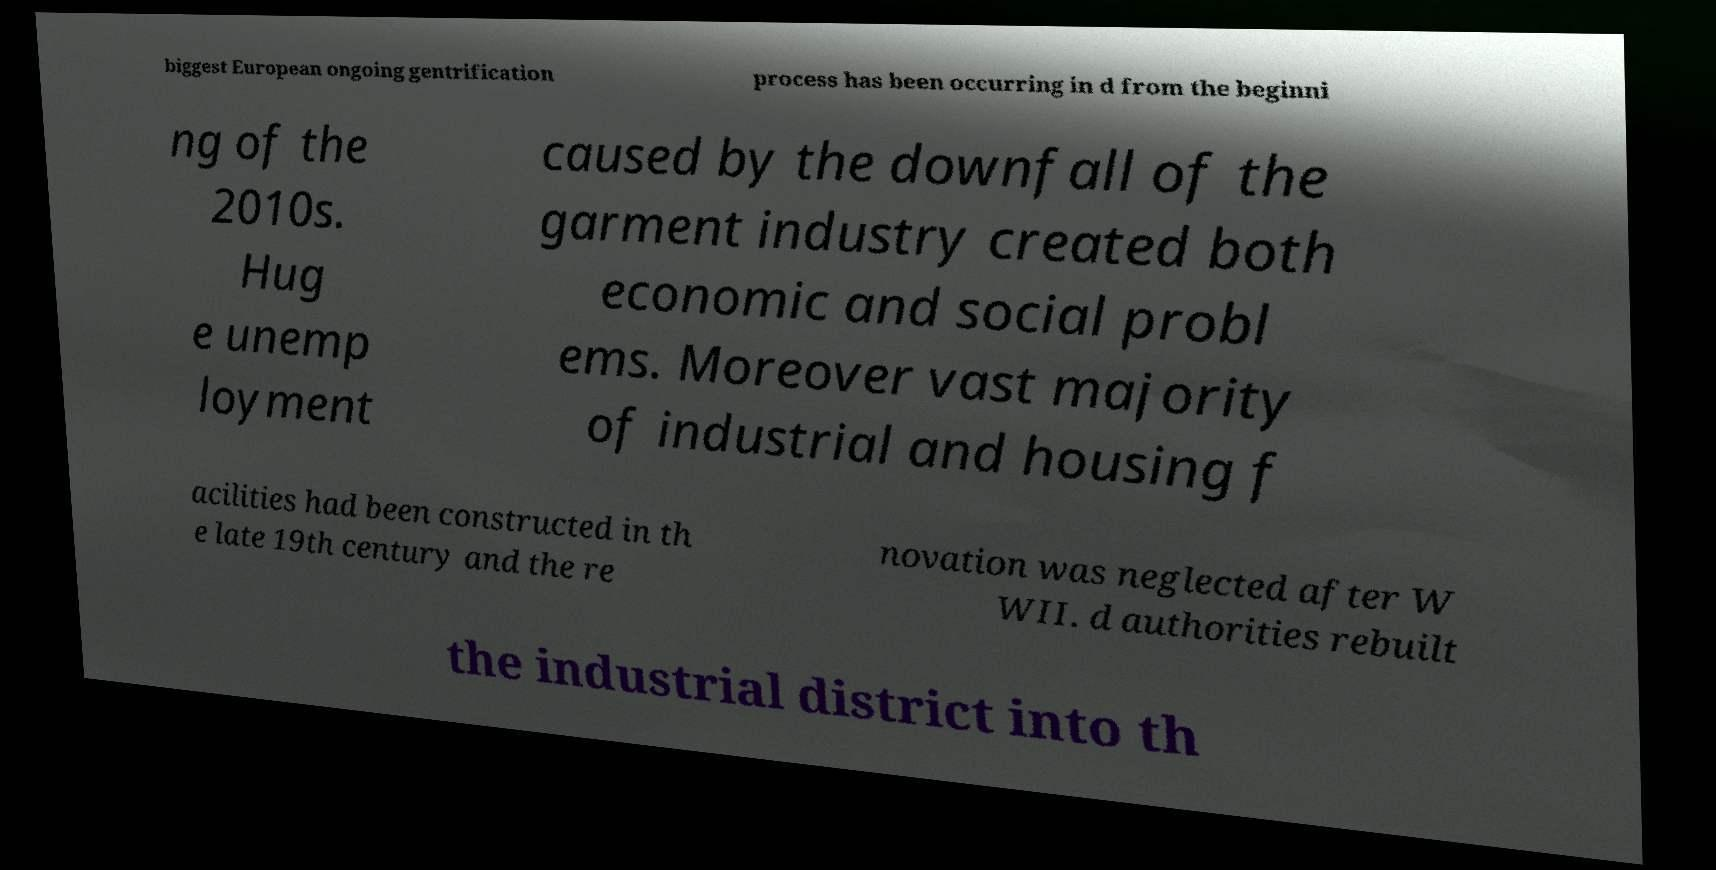Could you assist in decoding the text presented in this image and type it out clearly? biggest European ongoing gentrification process has been occurring in d from the beginni ng of the 2010s. Hug e unemp loyment caused by the downfall of the garment industry created both economic and social probl ems. Moreover vast majority of industrial and housing f acilities had been constructed in th e late 19th century and the re novation was neglected after W WII. d authorities rebuilt the industrial district into th 